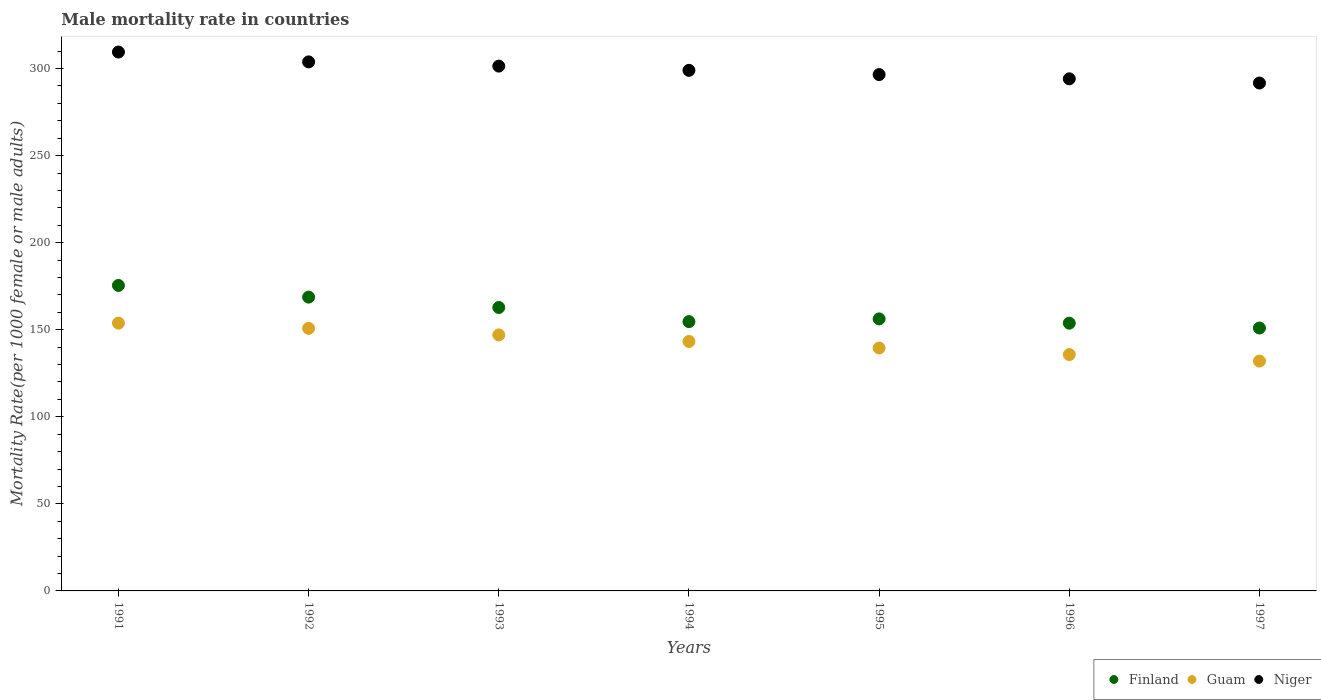How many different coloured dotlines are there?
Offer a terse response. 3. Is the number of dotlines equal to the number of legend labels?
Provide a short and direct response. Yes. What is the male mortality rate in Niger in 1993?
Your answer should be very brief. 301.38. Across all years, what is the maximum male mortality rate in Finland?
Offer a very short reply. 175.44. Across all years, what is the minimum male mortality rate in Finland?
Provide a succinct answer. 150.97. In which year was the male mortality rate in Guam minimum?
Your answer should be compact. 1997. What is the total male mortality rate in Finland in the graph?
Provide a succinct answer. 1122.53. What is the difference between the male mortality rate in Niger in 1991 and that in 1997?
Offer a terse response. 17.81. What is the difference between the male mortality rate in Guam in 1993 and the male mortality rate in Niger in 1997?
Ensure brevity in your answer.  -144.65. What is the average male mortality rate in Niger per year?
Make the answer very short. 299.41. In the year 1993, what is the difference between the male mortality rate in Guam and male mortality rate in Finland?
Provide a succinct answer. -15.75. In how many years, is the male mortality rate in Finland greater than 160?
Give a very brief answer. 3. What is the ratio of the male mortality rate in Finland in 1995 to that in 1996?
Ensure brevity in your answer.  1.02. Is the difference between the male mortality rate in Guam in 1992 and 1993 greater than the difference between the male mortality rate in Finland in 1992 and 1993?
Provide a short and direct response. No. What is the difference between the highest and the second highest male mortality rate in Guam?
Provide a succinct answer. 3.02. What is the difference between the highest and the lowest male mortality rate in Guam?
Your answer should be compact. 21.81. In how many years, is the male mortality rate in Guam greater than the average male mortality rate in Guam taken over all years?
Make the answer very short. 4. Is the sum of the male mortality rate in Finland in 1994 and 1995 greater than the maximum male mortality rate in Guam across all years?
Offer a very short reply. Yes. Is the male mortality rate in Finland strictly greater than the male mortality rate in Niger over the years?
Your answer should be compact. No. How many dotlines are there?
Make the answer very short. 3. How many years are there in the graph?
Provide a succinct answer. 7. Does the graph contain any zero values?
Your answer should be very brief. No. Does the graph contain grids?
Ensure brevity in your answer.  No. Where does the legend appear in the graph?
Your answer should be compact. Bottom right. What is the title of the graph?
Ensure brevity in your answer.  Male mortality rate in countries. Does "Solomon Islands" appear as one of the legend labels in the graph?
Make the answer very short. No. What is the label or title of the Y-axis?
Provide a succinct answer. Mortality Rate(per 1000 female or male adults). What is the Mortality Rate(per 1000 female or male adults) of Finland in 1991?
Make the answer very short. 175.44. What is the Mortality Rate(per 1000 female or male adults) of Guam in 1991?
Your answer should be very brief. 153.8. What is the Mortality Rate(per 1000 female or male adults) in Niger in 1991?
Give a very brief answer. 309.47. What is the Mortality Rate(per 1000 female or male adults) of Finland in 1992?
Make the answer very short. 168.72. What is the Mortality Rate(per 1000 female or male adults) in Guam in 1992?
Offer a very short reply. 150.77. What is the Mortality Rate(per 1000 female or male adults) in Niger in 1992?
Ensure brevity in your answer.  303.81. What is the Mortality Rate(per 1000 female or male adults) of Finland in 1993?
Give a very brief answer. 162.76. What is the Mortality Rate(per 1000 female or male adults) of Guam in 1993?
Offer a very short reply. 147.01. What is the Mortality Rate(per 1000 female or male adults) in Niger in 1993?
Provide a short and direct response. 301.38. What is the Mortality Rate(per 1000 female or male adults) of Finland in 1994?
Keep it short and to the point. 154.65. What is the Mortality Rate(per 1000 female or male adults) of Guam in 1994?
Offer a very short reply. 143.26. What is the Mortality Rate(per 1000 female or male adults) of Niger in 1994?
Your answer should be compact. 298.95. What is the Mortality Rate(per 1000 female or male adults) of Finland in 1995?
Keep it short and to the point. 156.22. What is the Mortality Rate(per 1000 female or male adults) in Guam in 1995?
Offer a terse response. 139.5. What is the Mortality Rate(per 1000 female or male adults) of Niger in 1995?
Your answer should be compact. 296.52. What is the Mortality Rate(per 1000 female or male adults) in Finland in 1996?
Offer a terse response. 153.76. What is the Mortality Rate(per 1000 female or male adults) of Guam in 1996?
Give a very brief answer. 135.74. What is the Mortality Rate(per 1000 female or male adults) of Niger in 1996?
Provide a short and direct response. 294.09. What is the Mortality Rate(per 1000 female or male adults) of Finland in 1997?
Offer a terse response. 150.97. What is the Mortality Rate(per 1000 female or male adults) in Guam in 1997?
Give a very brief answer. 131.98. What is the Mortality Rate(per 1000 female or male adults) in Niger in 1997?
Your answer should be compact. 291.66. Across all years, what is the maximum Mortality Rate(per 1000 female or male adults) of Finland?
Keep it short and to the point. 175.44. Across all years, what is the maximum Mortality Rate(per 1000 female or male adults) in Guam?
Ensure brevity in your answer.  153.8. Across all years, what is the maximum Mortality Rate(per 1000 female or male adults) in Niger?
Ensure brevity in your answer.  309.47. Across all years, what is the minimum Mortality Rate(per 1000 female or male adults) of Finland?
Ensure brevity in your answer.  150.97. Across all years, what is the minimum Mortality Rate(per 1000 female or male adults) in Guam?
Offer a terse response. 131.98. Across all years, what is the minimum Mortality Rate(per 1000 female or male adults) of Niger?
Your response must be concise. 291.66. What is the total Mortality Rate(per 1000 female or male adults) of Finland in the graph?
Your response must be concise. 1122.53. What is the total Mortality Rate(per 1000 female or male adults) in Guam in the graph?
Ensure brevity in your answer.  1002.06. What is the total Mortality Rate(per 1000 female or male adults) in Niger in the graph?
Provide a short and direct response. 2095.89. What is the difference between the Mortality Rate(per 1000 female or male adults) in Finland in 1991 and that in 1992?
Your answer should be very brief. 6.71. What is the difference between the Mortality Rate(per 1000 female or male adults) in Guam in 1991 and that in 1992?
Provide a short and direct response. 3.02. What is the difference between the Mortality Rate(per 1000 female or male adults) in Niger in 1991 and that in 1992?
Provide a succinct answer. 5.66. What is the difference between the Mortality Rate(per 1000 female or male adults) of Finland in 1991 and that in 1993?
Your answer should be compact. 12.67. What is the difference between the Mortality Rate(per 1000 female or male adults) of Guam in 1991 and that in 1993?
Your response must be concise. 6.78. What is the difference between the Mortality Rate(per 1000 female or male adults) of Niger in 1991 and that in 1993?
Provide a succinct answer. 8.09. What is the difference between the Mortality Rate(per 1000 female or male adults) of Finland in 1991 and that in 1994?
Your answer should be very brief. 20.78. What is the difference between the Mortality Rate(per 1000 female or male adults) in Guam in 1991 and that in 1994?
Give a very brief answer. 10.54. What is the difference between the Mortality Rate(per 1000 female or male adults) in Niger in 1991 and that in 1994?
Provide a short and direct response. 10.52. What is the difference between the Mortality Rate(per 1000 female or male adults) of Finland in 1991 and that in 1995?
Provide a short and direct response. 19.22. What is the difference between the Mortality Rate(per 1000 female or male adults) in Guam in 1991 and that in 1995?
Keep it short and to the point. 14.3. What is the difference between the Mortality Rate(per 1000 female or male adults) in Niger in 1991 and that in 1995?
Your answer should be compact. 12.95. What is the difference between the Mortality Rate(per 1000 female or male adults) of Finland in 1991 and that in 1996?
Offer a very short reply. 21.68. What is the difference between the Mortality Rate(per 1000 female or male adults) in Guam in 1991 and that in 1996?
Keep it short and to the point. 18.06. What is the difference between the Mortality Rate(per 1000 female or male adults) in Niger in 1991 and that in 1996?
Make the answer very short. 15.38. What is the difference between the Mortality Rate(per 1000 female or male adults) of Finland in 1991 and that in 1997?
Make the answer very short. 24.46. What is the difference between the Mortality Rate(per 1000 female or male adults) in Guam in 1991 and that in 1997?
Provide a short and direct response. 21.81. What is the difference between the Mortality Rate(per 1000 female or male adults) in Niger in 1991 and that in 1997?
Your answer should be very brief. 17.81. What is the difference between the Mortality Rate(per 1000 female or male adults) of Finland in 1992 and that in 1993?
Provide a succinct answer. 5.96. What is the difference between the Mortality Rate(per 1000 female or male adults) in Guam in 1992 and that in 1993?
Your response must be concise. 3.76. What is the difference between the Mortality Rate(per 1000 female or male adults) in Niger in 1992 and that in 1993?
Offer a terse response. 2.43. What is the difference between the Mortality Rate(per 1000 female or male adults) of Finland in 1992 and that in 1994?
Give a very brief answer. 14.07. What is the difference between the Mortality Rate(per 1000 female or male adults) in Guam in 1992 and that in 1994?
Offer a very short reply. 7.52. What is the difference between the Mortality Rate(per 1000 female or male adults) in Niger in 1992 and that in 1994?
Provide a succinct answer. 4.86. What is the difference between the Mortality Rate(per 1000 female or male adults) in Finland in 1992 and that in 1995?
Provide a succinct answer. 12.5. What is the difference between the Mortality Rate(per 1000 female or male adults) of Guam in 1992 and that in 1995?
Ensure brevity in your answer.  11.27. What is the difference between the Mortality Rate(per 1000 female or male adults) of Niger in 1992 and that in 1995?
Your answer should be very brief. 7.29. What is the difference between the Mortality Rate(per 1000 female or male adults) of Finland in 1992 and that in 1996?
Provide a succinct answer. 14.96. What is the difference between the Mortality Rate(per 1000 female or male adults) in Guam in 1992 and that in 1996?
Give a very brief answer. 15.03. What is the difference between the Mortality Rate(per 1000 female or male adults) of Niger in 1992 and that in 1996?
Your answer should be compact. 9.72. What is the difference between the Mortality Rate(per 1000 female or male adults) of Finland in 1992 and that in 1997?
Offer a terse response. 17.75. What is the difference between the Mortality Rate(per 1000 female or male adults) of Guam in 1992 and that in 1997?
Offer a very short reply. 18.79. What is the difference between the Mortality Rate(per 1000 female or male adults) of Niger in 1992 and that in 1997?
Offer a very short reply. 12.15. What is the difference between the Mortality Rate(per 1000 female or male adults) in Finland in 1993 and that in 1994?
Keep it short and to the point. 8.11. What is the difference between the Mortality Rate(per 1000 female or male adults) of Guam in 1993 and that in 1994?
Ensure brevity in your answer.  3.76. What is the difference between the Mortality Rate(per 1000 female or male adults) of Niger in 1993 and that in 1994?
Provide a short and direct response. 2.43. What is the difference between the Mortality Rate(per 1000 female or male adults) in Finland in 1993 and that in 1995?
Give a very brief answer. 6.54. What is the difference between the Mortality Rate(per 1000 female or male adults) of Guam in 1993 and that in 1995?
Your answer should be very brief. 7.52. What is the difference between the Mortality Rate(per 1000 female or male adults) in Niger in 1993 and that in 1995?
Your answer should be compact. 4.86. What is the difference between the Mortality Rate(per 1000 female or male adults) in Finland in 1993 and that in 1996?
Provide a succinct answer. 9.01. What is the difference between the Mortality Rate(per 1000 female or male adults) in Guam in 1993 and that in 1996?
Ensure brevity in your answer.  11.28. What is the difference between the Mortality Rate(per 1000 female or male adults) in Niger in 1993 and that in 1996?
Offer a very short reply. 7.29. What is the difference between the Mortality Rate(per 1000 female or male adults) of Finland in 1993 and that in 1997?
Your answer should be very brief. 11.79. What is the difference between the Mortality Rate(per 1000 female or male adults) in Guam in 1993 and that in 1997?
Ensure brevity in your answer.  15.03. What is the difference between the Mortality Rate(per 1000 female or male adults) of Niger in 1993 and that in 1997?
Ensure brevity in your answer.  9.72. What is the difference between the Mortality Rate(per 1000 female or male adults) of Finland in 1994 and that in 1995?
Give a very brief answer. -1.57. What is the difference between the Mortality Rate(per 1000 female or male adults) in Guam in 1994 and that in 1995?
Make the answer very short. 3.76. What is the difference between the Mortality Rate(per 1000 female or male adults) of Niger in 1994 and that in 1995?
Your response must be concise. 2.43. What is the difference between the Mortality Rate(per 1000 female or male adults) in Finland in 1994 and that in 1996?
Your response must be concise. 0.9. What is the difference between the Mortality Rate(per 1000 female or male adults) in Guam in 1994 and that in 1996?
Your answer should be very brief. 7.52. What is the difference between the Mortality Rate(per 1000 female or male adults) of Niger in 1994 and that in 1996?
Ensure brevity in your answer.  4.86. What is the difference between the Mortality Rate(per 1000 female or male adults) of Finland in 1994 and that in 1997?
Offer a terse response. 3.68. What is the difference between the Mortality Rate(per 1000 female or male adults) of Guam in 1994 and that in 1997?
Offer a terse response. 11.28. What is the difference between the Mortality Rate(per 1000 female or male adults) in Niger in 1994 and that in 1997?
Provide a succinct answer. 7.29. What is the difference between the Mortality Rate(per 1000 female or male adults) of Finland in 1995 and that in 1996?
Offer a terse response. 2.46. What is the difference between the Mortality Rate(per 1000 female or male adults) of Guam in 1995 and that in 1996?
Make the answer very short. 3.76. What is the difference between the Mortality Rate(per 1000 female or male adults) of Niger in 1995 and that in 1996?
Keep it short and to the point. 2.43. What is the difference between the Mortality Rate(per 1000 female or male adults) in Finland in 1995 and that in 1997?
Provide a short and direct response. 5.25. What is the difference between the Mortality Rate(per 1000 female or male adults) of Guam in 1995 and that in 1997?
Make the answer very short. 7.52. What is the difference between the Mortality Rate(per 1000 female or male adults) of Niger in 1995 and that in 1997?
Ensure brevity in your answer.  4.86. What is the difference between the Mortality Rate(per 1000 female or male adults) of Finland in 1996 and that in 1997?
Give a very brief answer. 2.78. What is the difference between the Mortality Rate(per 1000 female or male adults) of Guam in 1996 and that in 1997?
Provide a succinct answer. 3.76. What is the difference between the Mortality Rate(per 1000 female or male adults) of Niger in 1996 and that in 1997?
Provide a short and direct response. 2.43. What is the difference between the Mortality Rate(per 1000 female or male adults) in Finland in 1991 and the Mortality Rate(per 1000 female or male adults) in Guam in 1992?
Your answer should be compact. 24.66. What is the difference between the Mortality Rate(per 1000 female or male adults) in Finland in 1991 and the Mortality Rate(per 1000 female or male adults) in Niger in 1992?
Offer a very short reply. -128.38. What is the difference between the Mortality Rate(per 1000 female or male adults) in Guam in 1991 and the Mortality Rate(per 1000 female or male adults) in Niger in 1992?
Provide a succinct answer. -150.02. What is the difference between the Mortality Rate(per 1000 female or male adults) of Finland in 1991 and the Mortality Rate(per 1000 female or male adults) of Guam in 1993?
Your response must be concise. 28.42. What is the difference between the Mortality Rate(per 1000 female or male adults) of Finland in 1991 and the Mortality Rate(per 1000 female or male adults) of Niger in 1993?
Provide a succinct answer. -125.94. What is the difference between the Mortality Rate(per 1000 female or male adults) in Guam in 1991 and the Mortality Rate(per 1000 female or male adults) in Niger in 1993?
Ensure brevity in your answer.  -147.59. What is the difference between the Mortality Rate(per 1000 female or male adults) in Finland in 1991 and the Mortality Rate(per 1000 female or male adults) in Guam in 1994?
Keep it short and to the point. 32.18. What is the difference between the Mortality Rate(per 1000 female or male adults) in Finland in 1991 and the Mortality Rate(per 1000 female or male adults) in Niger in 1994?
Keep it short and to the point. -123.52. What is the difference between the Mortality Rate(per 1000 female or male adults) of Guam in 1991 and the Mortality Rate(per 1000 female or male adults) of Niger in 1994?
Provide a succinct answer. -145.16. What is the difference between the Mortality Rate(per 1000 female or male adults) of Finland in 1991 and the Mortality Rate(per 1000 female or male adults) of Guam in 1995?
Ensure brevity in your answer.  35.94. What is the difference between the Mortality Rate(per 1000 female or male adults) of Finland in 1991 and the Mortality Rate(per 1000 female or male adults) of Niger in 1995?
Offer a terse response. -121.08. What is the difference between the Mortality Rate(per 1000 female or male adults) in Guam in 1991 and the Mortality Rate(per 1000 female or male adults) in Niger in 1995?
Your response must be concise. -142.72. What is the difference between the Mortality Rate(per 1000 female or male adults) in Finland in 1991 and the Mortality Rate(per 1000 female or male adults) in Guam in 1996?
Offer a terse response. 39.7. What is the difference between the Mortality Rate(per 1000 female or male adults) of Finland in 1991 and the Mortality Rate(per 1000 female or male adults) of Niger in 1996?
Give a very brief answer. -118.65. What is the difference between the Mortality Rate(per 1000 female or male adults) of Guam in 1991 and the Mortality Rate(per 1000 female or male adults) of Niger in 1996?
Provide a short and direct response. -140.29. What is the difference between the Mortality Rate(per 1000 female or male adults) in Finland in 1991 and the Mortality Rate(per 1000 female or male adults) in Guam in 1997?
Ensure brevity in your answer.  43.45. What is the difference between the Mortality Rate(per 1000 female or male adults) in Finland in 1991 and the Mortality Rate(per 1000 female or male adults) in Niger in 1997?
Make the answer very short. -116.22. What is the difference between the Mortality Rate(per 1000 female or male adults) in Guam in 1991 and the Mortality Rate(per 1000 female or male adults) in Niger in 1997?
Provide a succinct answer. -137.87. What is the difference between the Mortality Rate(per 1000 female or male adults) of Finland in 1992 and the Mortality Rate(per 1000 female or male adults) of Guam in 1993?
Offer a very short reply. 21.71. What is the difference between the Mortality Rate(per 1000 female or male adults) in Finland in 1992 and the Mortality Rate(per 1000 female or male adults) in Niger in 1993?
Ensure brevity in your answer.  -132.66. What is the difference between the Mortality Rate(per 1000 female or male adults) of Guam in 1992 and the Mortality Rate(per 1000 female or male adults) of Niger in 1993?
Provide a succinct answer. -150.61. What is the difference between the Mortality Rate(per 1000 female or male adults) of Finland in 1992 and the Mortality Rate(per 1000 female or male adults) of Guam in 1994?
Provide a short and direct response. 25.46. What is the difference between the Mortality Rate(per 1000 female or male adults) of Finland in 1992 and the Mortality Rate(per 1000 female or male adults) of Niger in 1994?
Your answer should be compact. -130.23. What is the difference between the Mortality Rate(per 1000 female or male adults) of Guam in 1992 and the Mortality Rate(per 1000 female or male adults) of Niger in 1994?
Your answer should be compact. -148.18. What is the difference between the Mortality Rate(per 1000 female or male adults) in Finland in 1992 and the Mortality Rate(per 1000 female or male adults) in Guam in 1995?
Provide a short and direct response. 29.22. What is the difference between the Mortality Rate(per 1000 female or male adults) in Finland in 1992 and the Mortality Rate(per 1000 female or male adults) in Niger in 1995?
Offer a very short reply. -127.8. What is the difference between the Mortality Rate(per 1000 female or male adults) in Guam in 1992 and the Mortality Rate(per 1000 female or male adults) in Niger in 1995?
Make the answer very short. -145.75. What is the difference between the Mortality Rate(per 1000 female or male adults) in Finland in 1992 and the Mortality Rate(per 1000 female or male adults) in Guam in 1996?
Offer a terse response. 32.98. What is the difference between the Mortality Rate(per 1000 female or male adults) in Finland in 1992 and the Mortality Rate(per 1000 female or male adults) in Niger in 1996?
Your answer should be very brief. -125.37. What is the difference between the Mortality Rate(per 1000 female or male adults) in Guam in 1992 and the Mortality Rate(per 1000 female or male adults) in Niger in 1996?
Offer a very short reply. -143.32. What is the difference between the Mortality Rate(per 1000 female or male adults) of Finland in 1992 and the Mortality Rate(per 1000 female or male adults) of Guam in 1997?
Provide a succinct answer. 36.74. What is the difference between the Mortality Rate(per 1000 female or male adults) in Finland in 1992 and the Mortality Rate(per 1000 female or male adults) in Niger in 1997?
Provide a short and direct response. -122.94. What is the difference between the Mortality Rate(per 1000 female or male adults) of Guam in 1992 and the Mortality Rate(per 1000 female or male adults) of Niger in 1997?
Give a very brief answer. -140.89. What is the difference between the Mortality Rate(per 1000 female or male adults) in Finland in 1993 and the Mortality Rate(per 1000 female or male adults) in Guam in 1994?
Your answer should be very brief. 19.51. What is the difference between the Mortality Rate(per 1000 female or male adults) in Finland in 1993 and the Mortality Rate(per 1000 female or male adults) in Niger in 1994?
Provide a succinct answer. -136.19. What is the difference between the Mortality Rate(per 1000 female or male adults) in Guam in 1993 and the Mortality Rate(per 1000 female or male adults) in Niger in 1994?
Ensure brevity in your answer.  -151.94. What is the difference between the Mortality Rate(per 1000 female or male adults) in Finland in 1993 and the Mortality Rate(per 1000 female or male adults) in Guam in 1995?
Your response must be concise. 23.27. What is the difference between the Mortality Rate(per 1000 female or male adults) of Finland in 1993 and the Mortality Rate(per 1000 female or male adults) of Niger in 1995?
Ensure brevity in your answer.  -133.76. What is the difference between the Mortality Rate(per 1000 female or male adults) of Guam in 1993 and the Mortality Rate(per 1000 female or male adults) of Niger in 1995?
Your response must be concise. -149.51. What is the difference between the Mortality Rate(per 1000 female or male adults) in Finland in 1993 and the Mortality Rate(per 1000 female or male adults) in Guam in 1996?
Keep it short and to the point. 27.02. What is the difference between the Mortality Rate(per 1000 female or male adults) in Finland in 1993 and the Mortality Rate(per 1000 female or male adults) in Niger in 1996?
Your response must be concise. -131.33. What is the difference between the Mortality Rate(per 1000 female or male adults) of Guam in 1993 and the Mortality Rate(per 1000 female or male adults) of Niger in 1996?
Provide a succinct answer. -147.08. What is the difference between the Mortality Rate(per 1000 female or male adults) of Finland in 1993 and the Mortality Rate(per 1000 female or male adults) of Guam in 1997?
Your answer should be very brief. 30.78. What is the difference between the Mortality Rate(per 1000 female or male adults) of Finland in 1993 and the Mortality Rate(per 1000 female or male adults) of Niger in 1997?
Offer a terse response. -128.9. What is the difference between the Mortality Rate(per 1000 female or male adults) in Guam in 1993 and the Mortality Rate(per 1000 female or male adults) in Niger in 1997?
Provide a short and direct response. -144.65. What is the difference between the Mortality Rate(per 1000 female or male adults) of Finland in 1994 and the Mortality Rate(per 1000 female or male adults) of Guam in 1995?
Provide a succinct answer. 15.15. What is the difference between the Mortality Rate(per 1000 female or male adults) of Finland in 1994 and the Mortality Rate(per 1000 female or male adults) of Niger in 1995?
Keep it short and to the point. -141.87. What is the difference between the Mortality Rate(per 1000 female or male adults) in Guam in 1994 and the Mortality Rate(per 1000 female or male adults) in Niger in 1995?
Ensure brevity in your answer.  -153.26. What is the difference between the Mortality Rate(per 1000 female or male adults) of Finland in 1994 and the Mortality Rate(per 1000 female or male adults) of Guam in 1996?
Provide a short and direct response. 18.91. What is the difference between the Mortality Rate(per 1000 female or male adults) of Finland in 1994 and the Mortality Rate(per 1000 female or male adults) of Niger in 1996?
Provide a short and direct response. -139.44. What is the difference between the Mortality Rate(per 1000 female or male adults) of Guam in 1994 and the Mortality Rate(per 1000 female or male adults) of Niger in 1996?
Make the answer very short. -150.83. What is the difference between the Mortality Rate(per 1000 female or male adults) in Finland in 1994 and the Mortality Rate(per 1000 female or male adults) in Guam in 1997?
Ensure brevity in your answer.  22.67. What is the difference between the Mortality Rate(per 1000 female or male adults) in Finland in 1994 and the Mortality Rate(per 1000 female or male adults) in Niger in 1997?
Offer a very short reply. -137.01. What is the difference between the Mortality Rate(per 1000 female or male adults) in Guam in 1994 and the Mortality Rate(per 1000 female or male adults) in Niger in 1997?
Make the answer very short. -148.4. What is the difference between the Mortality Rate(per 1000 female or male adults) in Finland in 1995 and the Mortality Rate(per 1000 female or male adults) in Guam in 1996?
Ensure brevity in your answer.  20.48. What is the difference between the Mortality Rate(per 1000 female or male adults) of Finland in 1995 and the Mortality Rate(per 1000 female or male adults) of Niger in 1996?
Your response must be concise. -137.87. What is the difference between the Mortality Rate(per 1000 female or male adults) in Guam in 1995 and the Mortality Rate(per 1000 female or male adults) in Niger in 1996?
Give a very brief answer. -154.59. What is the difference between the Mortality Rate(per 1000 female or male adults) in Finland in 1995 and the Mortality Rate(per 1000 female or male adults) in Guam in 1997?
Make the answer very short. 24.24. What is the difference between the Mortality Rate(per 1000 female or male adults) in Finland in 1995 and the Mortality Rate(per 1000 female or male adults) in Niger in 1997?
Give a very brief answer. -135.44. What is the difference between the Mortality Rate(per 1000 female or male adults) in Guam in 1995 and the Mortality Rate(per 1000 female or male adults) in Niger in 1997?
Your answer should be compact. -152.16. What is the difference between the Mortality Rate(per 1000 female or male adults) of Finland in 1996 and the Mortality Rate(per 1000 female or male adults) of Guam in 1997?
Make the answer very short. 21.77. What is the difference between the Mortality Rate(per 1000 female or male adults) of Finland in 1996 and the Mortality Rate(per 1000 female or male adults) of Niger in 1997?
Provide a short and direct response. -137.9. What is the difference between the Mortality Rate(per 1000 female or male adults) of Guam in 1996 and the Mortality Rate(per 1000 female or male adults) of Niger in 1997?
Keep it short and to the point. -155.92. What is the average Mortality Rate(per 1000 female or male adults) of Finland per year?
Keep it short and to the point. 160.36. What is the average Mortality Rate(per 1000 female or male adults) of Guam per year?
Ensure brevity in your answer.  143.15. What is the average Mortality Rate(per 1000 female or male adults) in Niger per year?
Your response must be concise. 299.41. In the year 1991, what is the difference between the Mortality Rate(per 1000 female or male adults) in Finland and Mortality Rate(per 1000 female or male adults) in Guam?
Keep it short and to the point. 21.64. In the year 1991, what is the difference between the Mortality Rate(per 1000 female or male adults) of Finland and Mortality Rate(per 1000 female or male adults) of Niger?
Your answer should be very brief. -134.03. In the year 1991, what is the difference between the Mortality Rate(per 1000 female or male adults) of Guam and Mortality Rate(per 1000 female or male adults) of Niger?
Your answer should be compact. -155.68. In the year 1992, what is the difference between the Mortality Rate(per 1000 female or male adults) of Finland and Mortality Rate(per 1000 female or male adults) of Guam?
Your answer should be very brief. 17.95. In the year 1992, what is the difference between the Mortality Rate(per 1000 female or male adults) in Finland and Mortality Rate(per 1000 female or male adults) in Niger?
Make the answer very short. -135.09. In the year 1992, what is the difference between the Mortality Rate(per 1000 female or male adults) of Guam and Mortality Rate(per 1000 female or male adults) of Niger?
Provide a short and direct response. -153.04. In the year 1993, what is the difference between the Mortality Rate(per 1000 female or male adults) in Finland and Mortality Rate(per 1000 female or male adults) in Guam?
Give a very brief answer. 15.75. In the year 1993, what is the difference between the Mortality Rate(per 1000 female or male adults) in Finland and Mortality Rate(per 1000 female or male adults) in Niger?
Offer a terse response. -138.62. In the year 1993, what is the difference between the Mortality Rate(per 1000 female or male adults) of Guam and Mortality Rate(per 1000 female or male adults) of Niger?
Offer a terse response. -154.37. In the year 1994, what is the difference between the Mortality Rate(per 1000 female or male adults) in Finland and Mortality Rate(per 1000 female or male adults) in Guam?
Ensure brevity in your answer.  11.4. In the year 1994, what is the difference between the Mortality Rate(per 1000 female or male adults) in Finland and Mortality Rate(per 1000 female or male adults) in Niger?
Keep it short and to the point. -144.3. In the year 1994, what is the difference between the Mortality Rate(per 1000 female or male adults) of Guam and Mortality Rate(per 1000 female or male adults) of Niger?
Provide a succinct answer. -155.69. In the year 1995, what is the difference between the Mortality Rate(per 1000 female or male adults) in Finland and Mortality Rate(per 1000 female or male adults) in Guam?
Offer a terse response. 16.72. In the year 1995, what is the difference between the Mortality Rate(per 1000 female or male adults) of Finland and Mortality Rate(per 1000 female or male adults) of Niger?
Keep it short and to the point. -140.3. In the year 1995, what is the difference between the Mortality Rate(per 1000 female or male adults) of Guam and Mortality Rate(per 1000 female or male adults) of Niger?
Give a very brief answer. -157.02. In the year 1996, what is the difference between the Mortality Rate(per 1000 female or male adults) of Finland and Mortality Rate(per 1000 female or male adults) of Guam?
Keep it short and to the point. 18.02. In the year 1996, what is the difference between the Mortality Rate(per 1000 female or male adults) of Finland and Mortality Rate(per 1000 female or male adults) of Niger?
Provide a short and direct response. -140.33. In the year 1996, what is the difference between the Mortality Rate(per 1000 female or male adults) in Guam and Mortality Rate(per 1000 female or male adults) in Niger?
Offer a very short reply. -158.35. In the year 1997, what is the difference between the Mortality Rate(per 1000 female or male adults) of Finland and Mortality Rate(per 1000 female or male adults) of Guam?
Offer a very short reply. 18.99. In the year 1997, what is the difference between the Mortality Rate(per 1000 female or male adults) of Finland and Mortality Rate(per 1000 female or male adults) of Niger?
Your response must be concise. -140.69. In the year 1997, what is the difference between the Mortality Rate(per 1000 female or male adults) of Guam and Mortality Rate(per 1000 female or male adults) of Niger?
Make the answer very short. -159.68. What is the ratio of the Mortality Rate(per 1000 female or male adults) in Finland in 1991 to that in 1992?
Make the answer very short. 1.04. What is the ratio of the Mortality Rate(per 1000 female or male adults) in Guam in 1991 to that in 1992?
Your response must be concise. 1.02. What is the ratio of the Mortality Rate(per 1000 female or male adults) in Niger in 1991 to that in 1992?
Provide a short and direct response. 1.02. What is the ratio of the Mortality Rate(per 1000 female or male adults) of Finland in 1991 to that in 1993?
Provide a short and direct response. 1.08. What is the ratio of the Mortality Rate(per 1000 female or male adults) in Guam in 1991 to that in 1993?
Make the answer very short. 1.05. What is the ratio of the Mortality Rate(per 1000 female or male adults) of Niger in 1991 to that in 1993?
Keep it short and to the point. 1.03. What is the ratio of the Mortality Rate(per 1000 female or male adults) in Finland in 1991 to that in 1994?
Offer a terse response. 1.13. What is the ratio of the Mortality Rate(per 1000 female or male adults) in Guam in 1991 to that in 1994?
Offer a terse response. 1.07. What is the ratio of the Mortality Rate(per 1000 female or male adults) in Niger in 1991 to that in 1994?
Your response must be concise. 1.04. What is the ratio of the Mortality Rate(per 1000 female or male adults) in Finland in 1991 to that in 1995?
Provide a short and direct response. 1.12. What is the ratio of the Mortality Rate(per 1000 female or male adults) in Guam in 1991 to that in 1995?
Provide a short and direct response. 1.1. What is the ratio of the Mortality Rate(per 1000 female or male adults) in Niger in 1991 to that in 1995?
Provide a succinct answer. 1.04. What is the ratio of the Mortality Rate(per 1000 female or male adults) of Finland in 1991 to that in 1996?
Ensure brevity in your answer.  1.14. What is the ratio of the Mortality Rate(per 1000 female or male adults) of Guam in 1991 to that in 1996?
Your response must be concise. 1.13. What is the ratio of the Mortality Rate(per 1000 female or male adults) of Niger in 1991 to that in 1996?
Make the answer very short. 1.05. What is the ratio of the Mortality Rate(per 1000 female or male adults) of Finland in 1991 to that in 1997?
Give a very brief answer. 1.16. What is the ratio of the Mortality Rate(per 1000 female or male adults) of Guam in 1991 to that in 1997?
Offer a terse response. 1.17. What is the ratio of the Mortality Rate(per 1000 female or male adults) in Niger in 1991 to that in 1997?
Provide a short and direct response. 1.06. What is the ratio of the Mortality Rate(per 1000 female or male adults) of Finland in 1992 to that in 1993?
Make the answer very short. 1.04. What is the ratio of the Mortality Rate(per 1000 female or male adults) in Guam in 1992 to that in 1993?
Offer a terse response. 1.03. What is the ratio of the Mortality Rate(per 1000 female or male adults) in Finland in 1992 to that in 1994?
Provide a succinct answer. 1.09. What is the ratio of the Mortality Rate(per 1000 female or male adults) in Guam in 1992 to that in 1994?
Your answer should be very brief. 1.05. What is the ratio of the Mortality Rate(per 1000 female or male adults) of Niger in 1992 to that in 1994?
Offer a terse response. 1.02. What is the ratio of the Mortality Rate(per 1000 female or male adults) of Finland in 1992 to that in 1995?
Make the answer very short. 1.08. What is the ratio of the Mortality Rate(per 1000 female or male adults) in Guam in 1992 to that in 1995?
Ensure brevity in your answer.  1.08. What is the ratio of the Mortality Rate(per 1000 female or male adults) of Niger in 1992 to that in 1995?
Provide a short and direct response. 1.02. What is the ratio of the Mortality Rate(per 1000 female or male adults) in Finland in 1992 to that in 1996?
Your answer should be compact. 1.1. What is the ratio of the Mortality Rate(per 1000 female or male adults) in Guam in 1992 to that in 1996?
Provide a succinct answer. 1.11. What is the ratio of the Mortality Rate(per 1000 female or male adults) in Niger in 1992 to that in 1996?
Make the answer very short. 1.03. What is the ratio of the Mortality Rate(per 1000 female or male adults) in Finland in 1992 to that in 1997?
Your answer should be very brief. 1.12. What is the ratio of the Mortality Rate(per 1000 female or male adults) of Guam in 1992 to that in 1997?
Keep it short and to the point. 1.14. What is the ratio of the Mortality Rate(per 1000 female or male adults) in Niger in 1992 to that in 1997?
Offer a terse response. 1.04. What is the ratio of the Mortality Rate(per 1000 female or male adults) of Finland in 1993 to that in 1994?
Keep it short and to the point. 1.05. What is the ratio of the Mortality Rate(per 1000 female or male adults) of Guam in 1993 to that in 1994?
Offer a terse response. 1.03. What is the ratio of the Mortality Rate(per 1000 female or male adults) in Niger in 1993 to that in 1994?
Provide a succinct answer. 1.01. What is the ratio of the Mortality Rate(per 1000 female or male adults) in Finland in 1993 to that in 1995?
Give a very brief answer. 1.04. What is the ratio of the Mortality Rate(per 1000 female or male adults) of Guam in 1993 to that in 1995?
Offer a terse response. 1.05. What is the ratio of the Mortality Rate(per 1000 female or male adults) in Niger in 1993 to that in 1995?
Offer a terse response. 1.02. What is the ratio of the Mortality Rate(per 1000 female or male adults) in Finland in 1993 to that in 1996?
Provide a short and direct response. 1.06. What is the ratio of the Mortality Rate(per 1000 female or male adults) of Guam in 1993 to that in 1996?
Provide a succinct answer. 1.08. What is the ratio of the Mortality Rate(per 1000 female or male adults) of Niger in 1993 to that in 1996?
Make the answer very short. 1.02. What is the ratio of the Mortality Rate(per 1000 female or male adults) in Finland in 1993 to that in 1997?
Offer a very short reply. 1.08. What is the ratio of the Mortality Rate(per 1000 female or male adults) of Guam in 1993 to that in 1997?
Keep it short and to the point. 1.11. What is the ratio of the Mortality Rate(per 1000 female or male adults) of Guam in 1994 to that in 1995?
Provide a short and direct response. 1.03. What is the ratio of the Mortality Rate(per 1000 female or male adults) of Niger in 1994 to that in 1995?
Make the answer very short. 1.01. What is the ratio of the Mortality Rate(per 1000 female or male adults) of Finland in 1994 to that in 1996?
Provide a succinct answer. 1.01. What is the ratio of the Mortality Rate(per 1000 female or male adults) of Guam in 1994 to that in 1996?
Your response must be concise. 1.06. What is the ratio of the Mortality Rate(per 1000 female or male adults) in Niger in 1994 to that in 1996?
Ensure brevity in your answer.  1.02. What is the ratio of the Mortality Rate(per 1000 female or male adults) of Finland in 1994 to that in 1997?
Give a very brief answer. 1.02. What is the ratio of the Mortality Rate(per 1000 female or male adults) of Guam in 1994 to that in 1997?
Ensure brevity in your answer.  1.09. What is the ratio of the Mortality Rate(per 1000 female or male adults) of Niger in 1994 to that in 1997?
Give a very brief answer. 1.02. What is the ratio of the Mortality Rate(per 1000 female or male adults) of Guam in 1995 to that in 1996?
Give a very brief answer. 1.03. What is the ratio of the Mortality Rate(per 1000 female or male adults) in Niger in 1995 to that in 1996?
Offer a very short reply. 1.01. What is the ratio of the Mortality Rate(per 1000 female or male adults) of Finland in 1995 to that in 1997?
Ensure brevity in your answer.  1.03. What is the ratio of the Mortality Rate(per 1000 female or male adults) in Guam in 1995 to that in 1997?
Provide a succinct answer. 1.06. What is the ratio of the Mortality Rate(per 1000 female or male adults) in Niger in 1995 to that in 1997?
Keep it short and to the point. 1.02. What is the ratio of the Mortality Rate(per 1000 female or male adults) of Finland in 1996 to that in 1997?
Offer a very short reply. 1.02. What is the ratio of the Mortality Rate(per 1000 female or male adults) of Guam in 1996 to that in 1997?
Give a very brief answer. 1.03. What is the ratio of the Mortality Rate(per 1000 female or male adults) of Niger in 1996 to that in 1997?
Make the answer very short. 1.01. What is the difference between the highest and the second highest Mortality Rate(per 1000 female or male adults) in Finland?
Your answer should be compact. 6.71. What is the difference between the highest and the second highest Mortality Rate(per 1000 female or male adults) in Guam?
Make the answer very short. 3.02. What is the difference between the highest and the second highest Mortality Rate(per 1000 female or male adults) of Niger?
Your answer should be compact. 5.66. What is the difference between the highest and the lowest Mortality Rate(per 1000 female or male adults) in Finland?
Offer a terse response. 24.46. What is the difference between the highest and the lowest Mortality Rate(per 1000 female or male adults) in Guam?
Your answer should be compact. 21.81. What is the difference between the highest and the lowest Mortality Rate(per 1000 female or male adults) in Niger?
Your response must be concise. 17.81. 